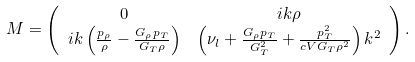<formula> <loc_0><loc_0><loc_500><loc_500>M & = \left ( { \begin{array} { c c } 0 & i k \rho \\ i k \left ( \frac { p _ { \rho } } { \rho } - \frac { G _ { \rho } p _ { T } } { G _ { T } \rho } \right ) & \left ( \nu _ { l } + \frac { G _ { \rho } p _ { T } } { G _ { T } ^ { 2 } } + \frac { p _ { T } ^ { 2 } } { c V G _ { T } \rho ^ { 2 } } \right ) k ^ { 2 } \end{array} } \right ) .</formula> 